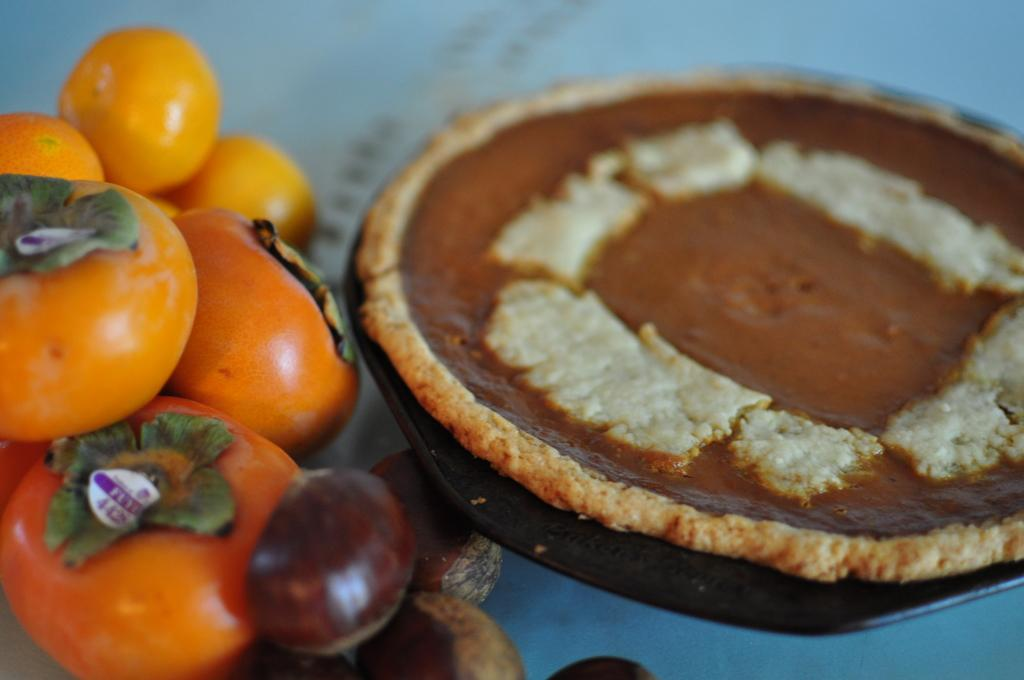What type of food can be seen in the image? There are fruits in the image. What colors are the fruits? The fruits have orange and brown colors. What is the plate used for in the image? The plate is used to contain food in the image. What color is the background of the image? The background of the image is white. What type of smoke can be seen coming from the fruits in the image? There is no smoke present in the image; it features fruits with orange and brown colors on a plate. What type of bells are hanging from the fruits in the image? There are no bells present in the image; it only features fruits on a plate. 